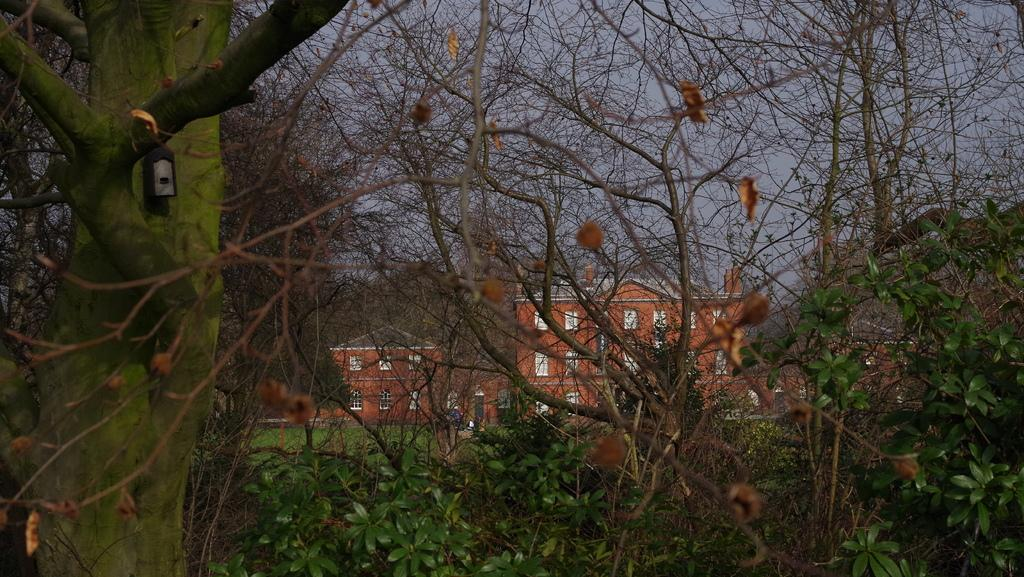What type of structures can be seen in the image? There are buildings in the image. What is located in front of the buildings? There is a grassland in front of the buildings. What type of vegetation is present on the front side of the image? There are plants and trees on the front side of the image. What can be seen behind the buildings? The sky is visible behind the buildings. What type of coal is being used to fuel the buildings in the image? There is no coal present in the image, and the buildings are not depicted as being fueled by coal. 